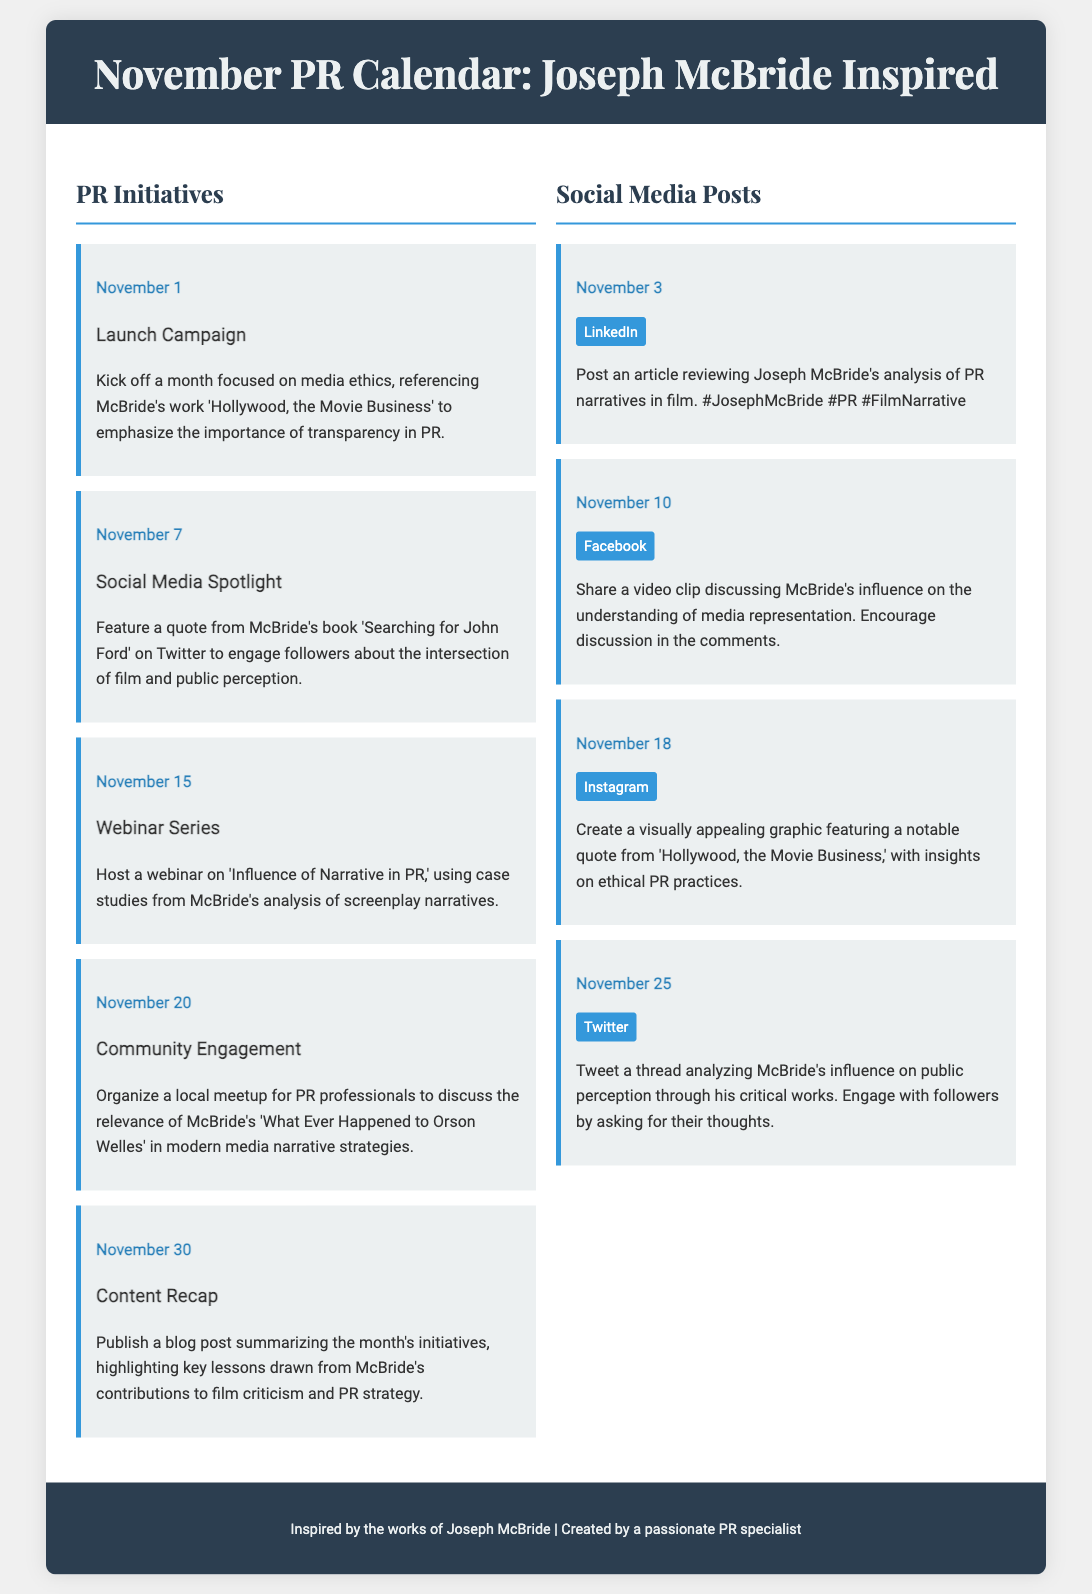What is the title of the document? The title of the document is specified in the header at the top of the page.
Answer: November PR Calendar: Joseph McBride Inspired What is the first PR initiative date? The first PR initiative is listed under the PR Initiatives section and corresponds to the date mentioned there.
Answer: November 1 Which book is referenced in the Launch Campaign? The book referenced in the Launch Campaign is noted in the description of the initiative.
Answer: Hollywood, the Movie Business What is featured on November 10 in social media? The content of the social media post for November 10 is detailed in the corresponding social post section.
Answer: Video clip discussing McBride's influence How many PR initiatives are there in total? The total number of PR initiatives is counted in the PR Initiatives section of the document.
Answer: Five What type of event is scheduled for November 15? The type of event scheduled is stated clearly in the initiative's description for that date.
Answer: Webinar Which social media platform is mentioned for a notable graphic on November 18? The social media platform for the graphic content is specified in the description of the social media post for that date.
Answer: Instagram What is the focus of the webinar series hosted on November 15? The focus is indicated in the description of the webinar initiative.
Answer: Influence of Narrative in PR Which McBride's work is discussed in the Community Engagement initiative? The work mentioned in the Community Engagement initiative is referenced in the description.
Answer: What Ever Happened to Orson Welles 